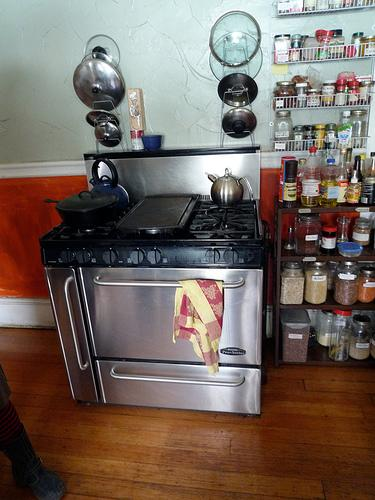What is next to the oven? spices 